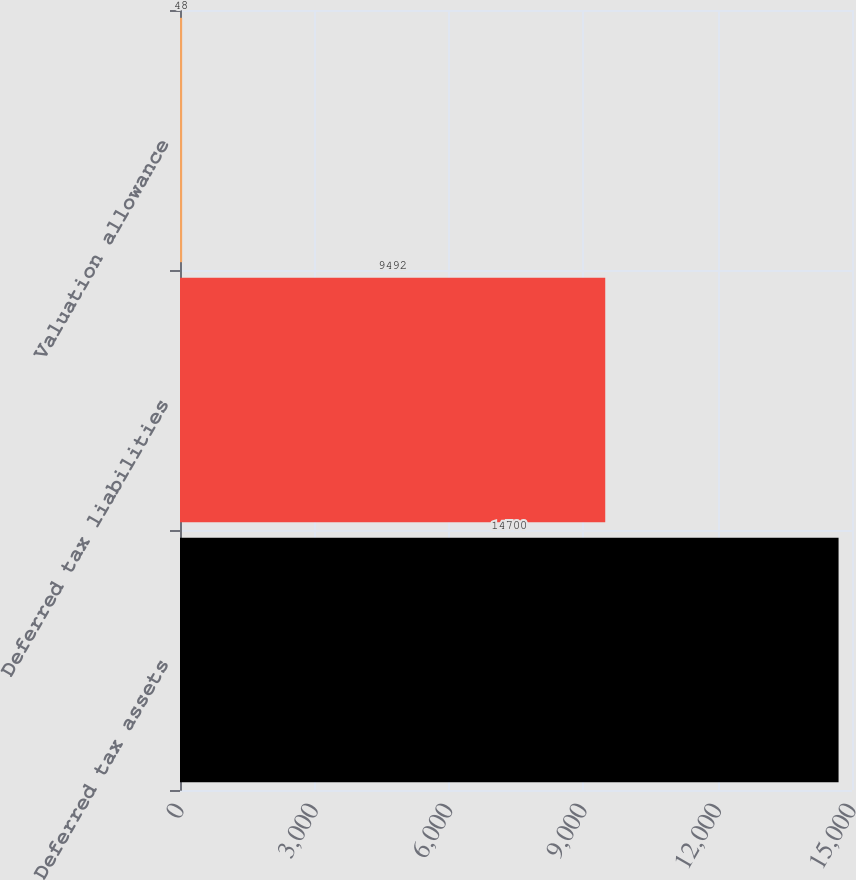<chart> <loc_0><loc_0><loc_500><loc_500><bar_chart><fcel>Deferred tax assets<fcel>Deferred tax liabilities<fcel>Valuation allowance<nl><fcel>14700<fcel>9492<fcel>48<nl></chart> 